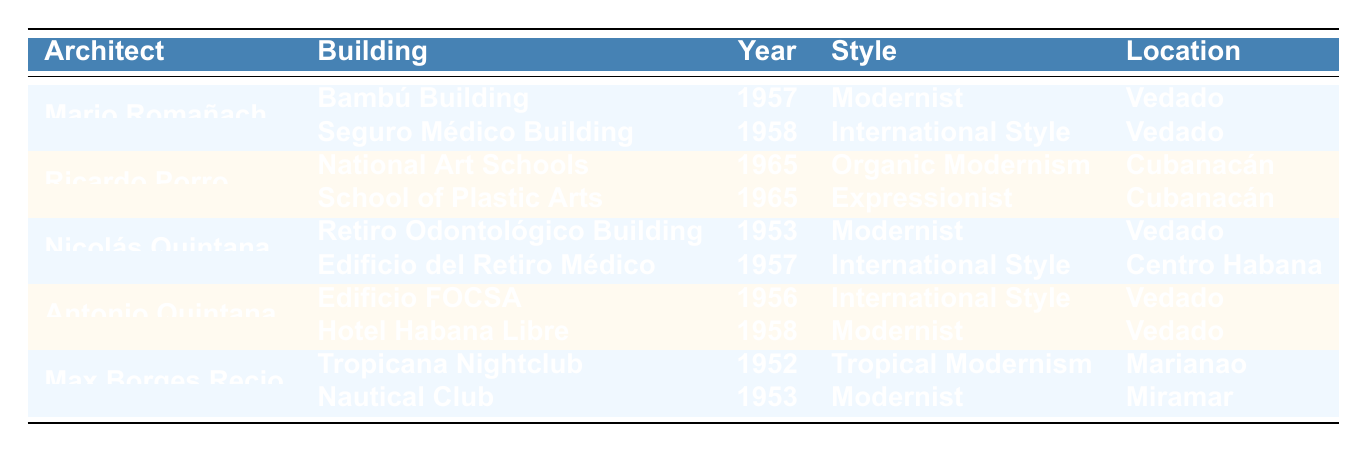What is the architectural style of the Bambú Building? The table states that the Bambú Building, designed by Mario Romañach, has an architectural style listed as "Modernist."
Answer: Modernist Which architect designed the Hotel Habana Libre? The table shows that the Hotel Habana Libre was designed by Antonio Quintana.
Answer: Antonio Quintana How many buildings did Ricardo Porro complete in 1965? According to the table, Ricardo Porro completed two buildings in 1965: the National Art Schools and the School of Plastic Arts.
Answer: 2 Is the Nautical Club located in Vedado? The table indicates that the Nautical Club is located in Miramar, not Vedado.
Answer: No Which architect has the most notable works listed in the table? The table shows each architect has either two or more notable works, but there is no architect with more than two works, indicating they are equal.
Answer: None What year was the Retiro Odontológico Building completed? The data in the table states that the Retiro Odontológico Building was completed in 1953.
Answer: 1953 List the locations of all buildings designed by Max Borges Recio. The table states that Max Borges Recio designed the Tropicana Nightclub in Marianao and the Nautical Club in Miramar.
Answer: Marianao and Miramar Which architectural styles are represented by buildings completed in the 1950s? Based on the table, the architectural styles in the 1950s include Modernist, International Style, and Tropical Modernism, as seen in buildings like the Hotel Habana Libre and Seguro Médico Building.
Answer: Modernist, International Style, Tropical Modernism How many buildings designed by Nicolás Quintana have an International Style? The table reveals that Nicolás Quintana designed one building, the Edificio del Retiro Médico, which falls under the International Style category.
Answer: 1 What is the average year of completion for the buildings listed in the table? To find the average, we sum the years of completion (1952 + 1953 + 1953 + 1956 + 1957 + 1957 + 1958 + 1958 + 1965 + 1965 = 1955.3) and then divide by the total number of buildings (10). The result is approximately 1955.
Answer: 1955 Count the number of buildings completed after 1960. The table shows that two buildings were completed after 1960: the National Art Schools and the School of Plastic Arts, both in 1965.
Answer: 2 